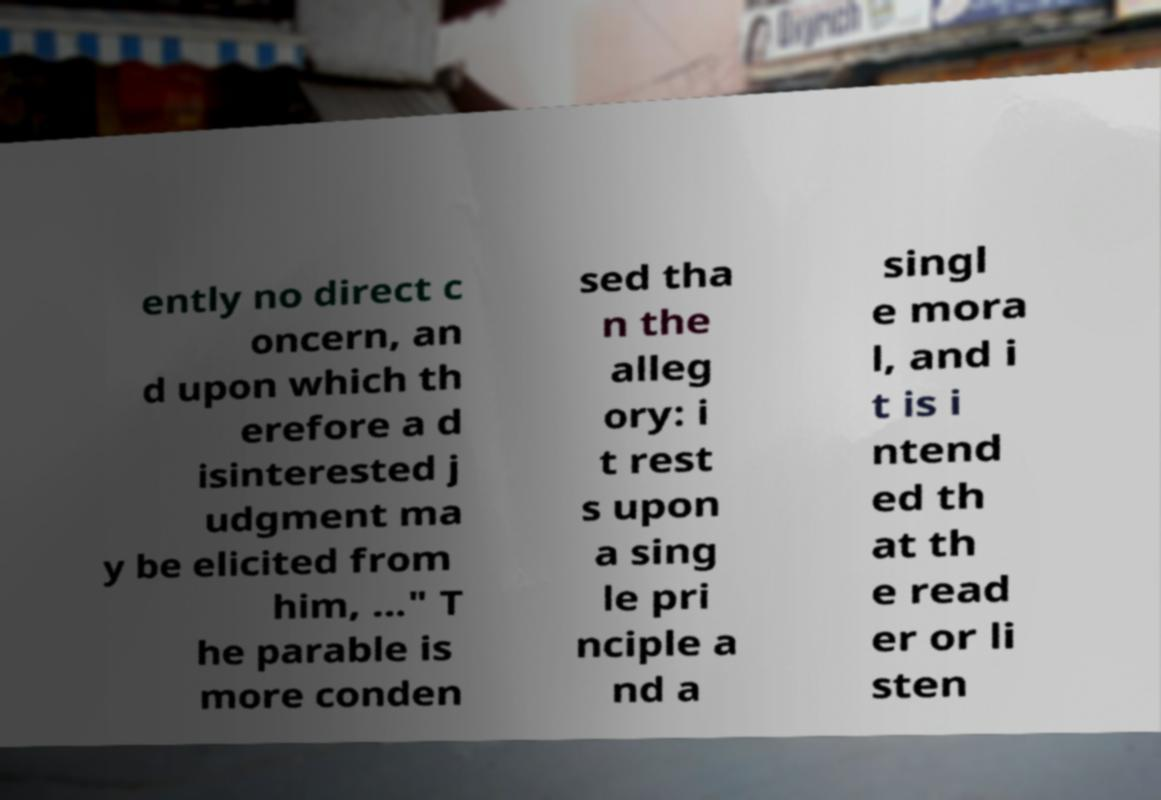Please identify and transcribe the text found in this image. ently no direct c oncern, an d upon which th erefore a d isinterested j udgment ma y be elicited from him, ..." T he parable is more conden sed tha n the alleg ory: i t rest s upon a sing le pri nciple a nd a singl e mora l, and i t is i ntend ed th at th e read er or li sten 